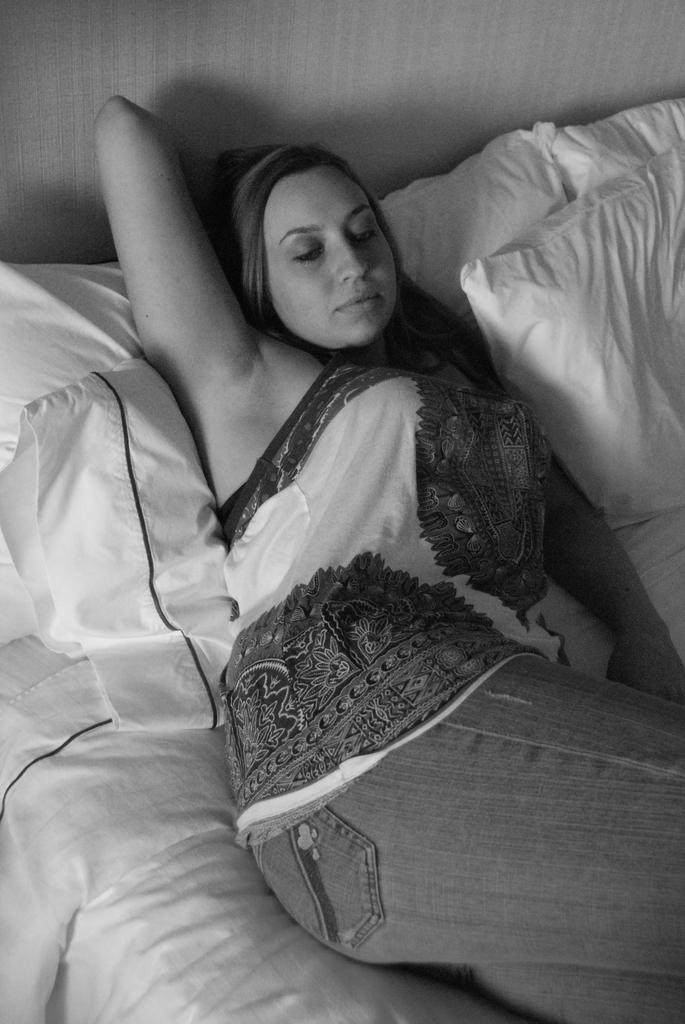What is the color scheme of the image? The image is black and white. Who is present in the image? There is a woman in the image. What is the woman wearing? The woman is wearing a white dress. What is the woman doing in the image? The woman is lying on a bed. What can be seen on the bed besides the woman? There are white-colored pillows on the bed. What is visible behind the woman? There is a wall behind the woman. What type of ear is visible on the floor in the image? There is no ear visible on the floor in the image. What sound can be heard coming from the wall in the image? There is no sound present in the image, as it is a still photograph. 